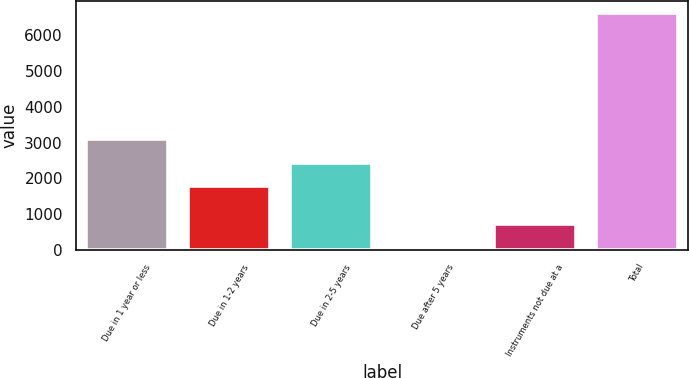Convert chart. <chart><loc_0><loc_0><loc_500><loc_500><bar_chart><fcel>Due in 1 year or less<fcel>Due in 1-2 years<fcel>Due in 2-5 years<fcel>Due after 5 years<fcel>Instruments not due at a<fcel>Total<nl><fcel>3086<fcel>1776<fcel>2431<fcel>71<fcel>726<fcel>6621<nl></chart> 